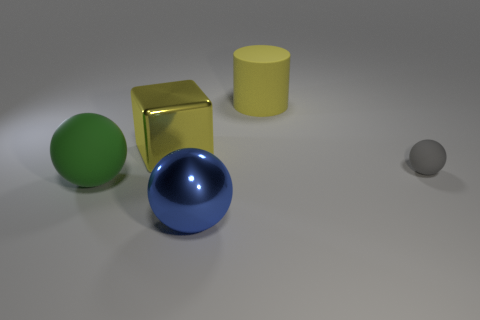Add 4 small blue matte cubes. How many objects exist? 9 Subtract all cubes. How many objects are left? 4 Add 3 large yellow metallic objects. How many large yellow metallic objects exist? 4 Subtract 0 purple cylinders. How many objects are left? 5 Subtract all blue rubber balls. Subtract all large yellow matte things. How many objects are left? 4 Add 2 yellow cylinders. How many yellow cylinders are left? 3 